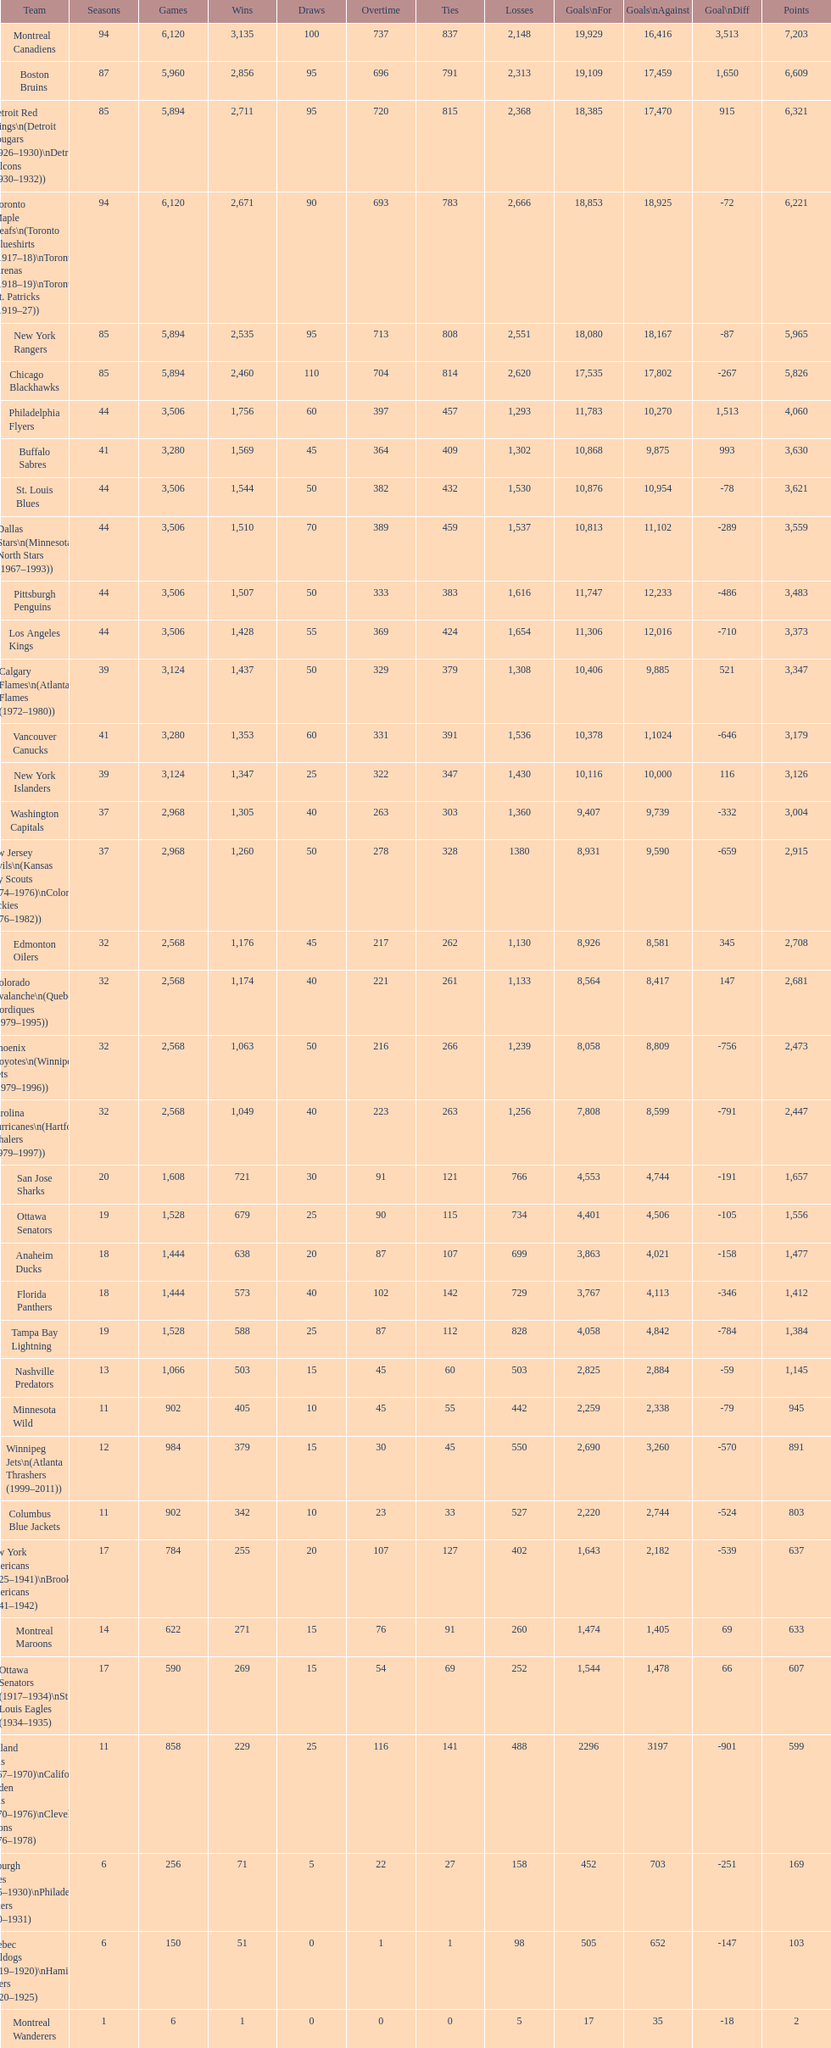Which team was last in terms of points up until this point? Montreal Wanderers. 